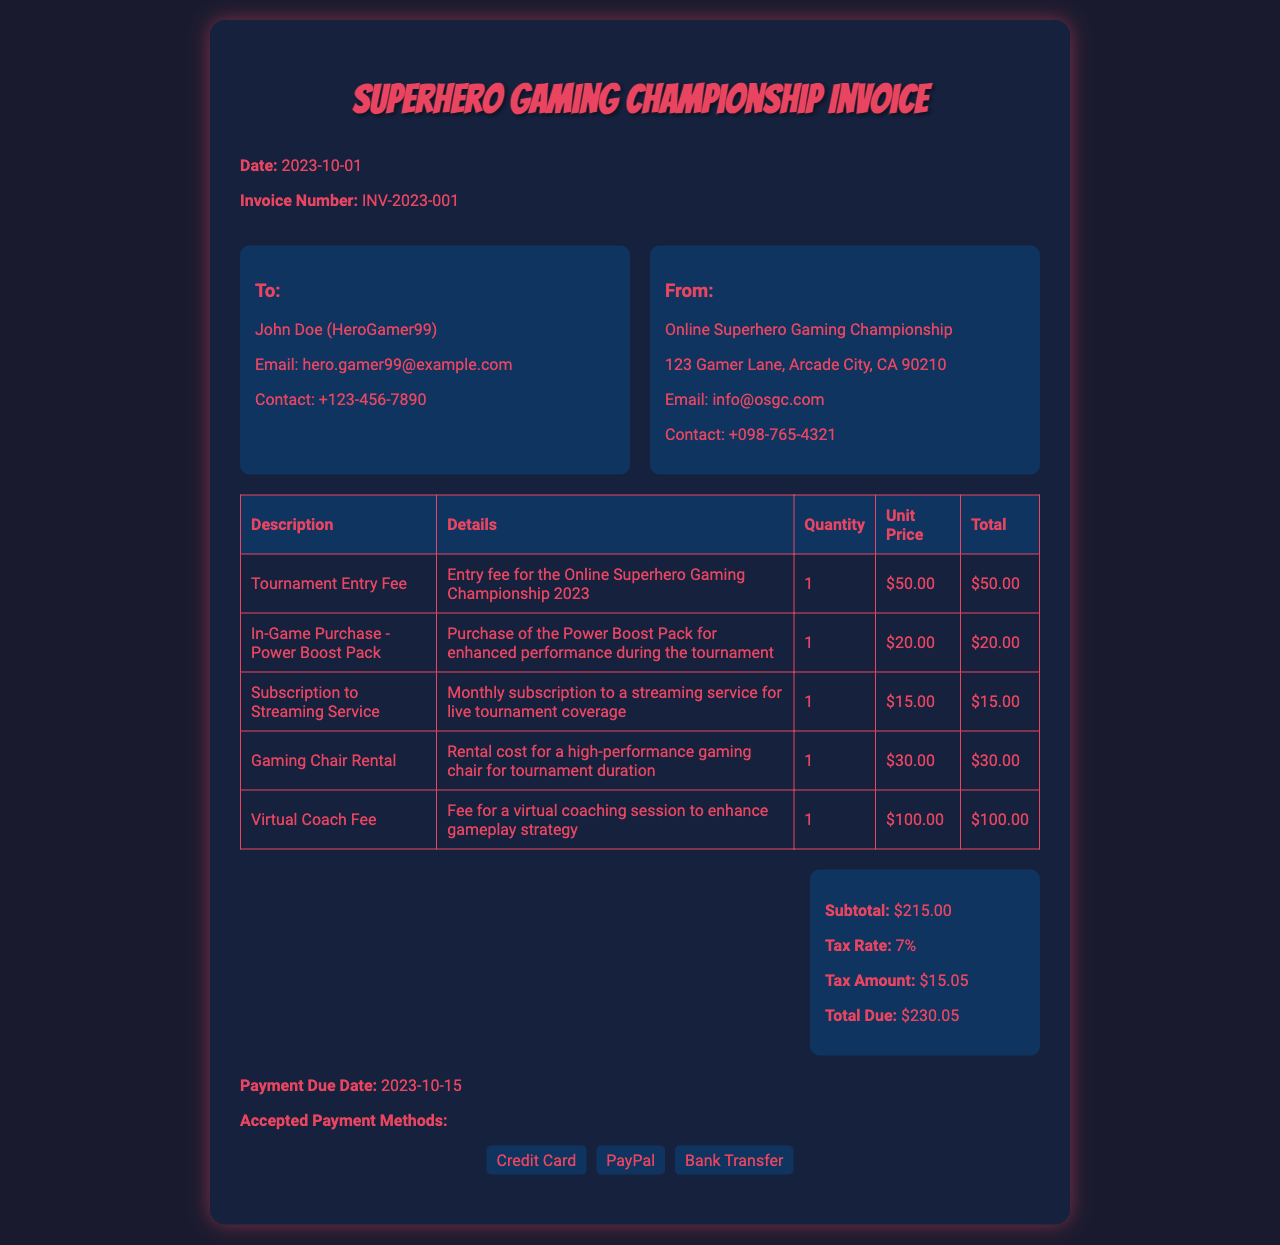What is the invoice number? The invoice number is listed in the document for reference, which is unique for each invoice.
Answer: INV-2023-001 Who is the recipient of the invoice? The recipient's name and gamer tag are provided in the "To" section of the document.
Answer: John Doe (HeroGamer99) What is the total due amount? The total due amount is calculated and displayed in the summary section.
Answer: $230.05 What is the date of the invoice? The date when the invoice was created is mentioned at the top of the document.
Answer: 2023-10-01 What item has the highest cost? This requires looking through the listed items and their total prices to find the one that costs the most.
Answer: Virtual Coach Fee How much is the tax amount? The tax amount is clearly stated in the summary section as part of the total calculation.
Answer: $15.05 What payment methods are accepted? The document includes a list of methods available for payment at the bottom section.
Answer: Credit Card, PayPal, Bank Transfer What is the payment due date? The date by which the payment should be made is listed in the document.
Answer: 2023-10-15 How many items are listed in the invoice? The number of items can be determined by counting the rows in the items section.
Answer: 5 